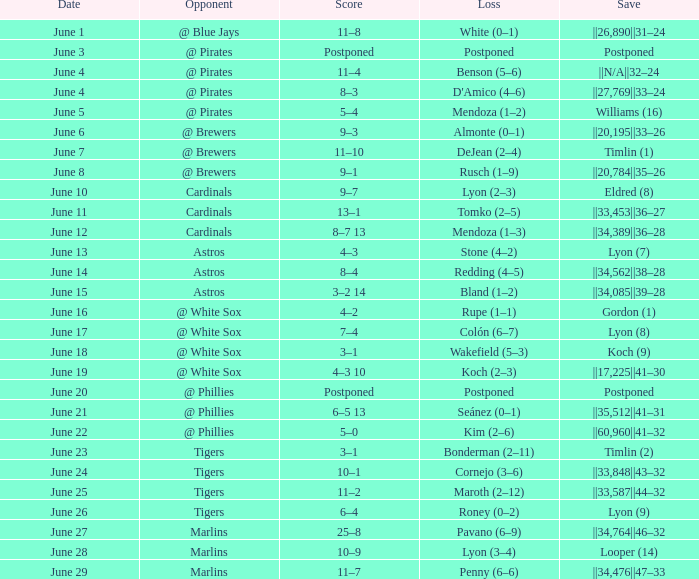Who is the rival having a save of ||33,453||36–27? Cardinals. 